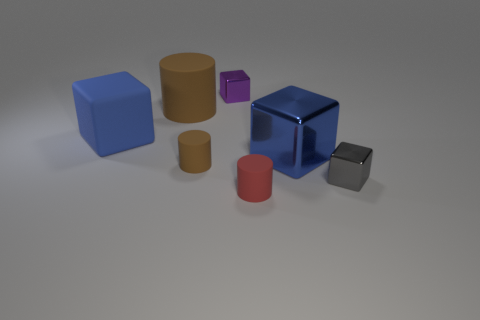How many big cyan metallic cylinders are there?
Give a very brief answer. 0. What color is the block that is made of the same material as the tiny brown cylinder?
Keep it short and to the point. Blue. How many large objects are matte objects or red rubber cylinders?
Offer a terse response. 2. There is a large matte cylinder; how many blue metal blocks are on the left side of it?
Give a very brief answer. 0. The big rubber thing that is the same shape as the purple shiny object is what color?
Ensure brevity in your answer.  Blue. What number of metal objects are either small purple objects or red cylinders?
Keep it short and to the point. 1. Are there any tiny gray metallic objects behind the tiny metallic object that is on the right side of the small shiny object on the left side of the red thing?
Keep it short and to the point. No. The rubber cube is what color?
Make the answer very short. Blue. Is the shape of the tiny metallic thing that is to the right of the red matte thing the same as  the small brown rubber object?
Offer a terse response. No. How many things are either large brown rubber cylinders or large things that are left of the red rubber cylinder?
Provide a succinct answer. 2. 